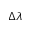<formula> <loc_0><loc_0><loc_500><loc_500>\Delta \lambda</formula> 